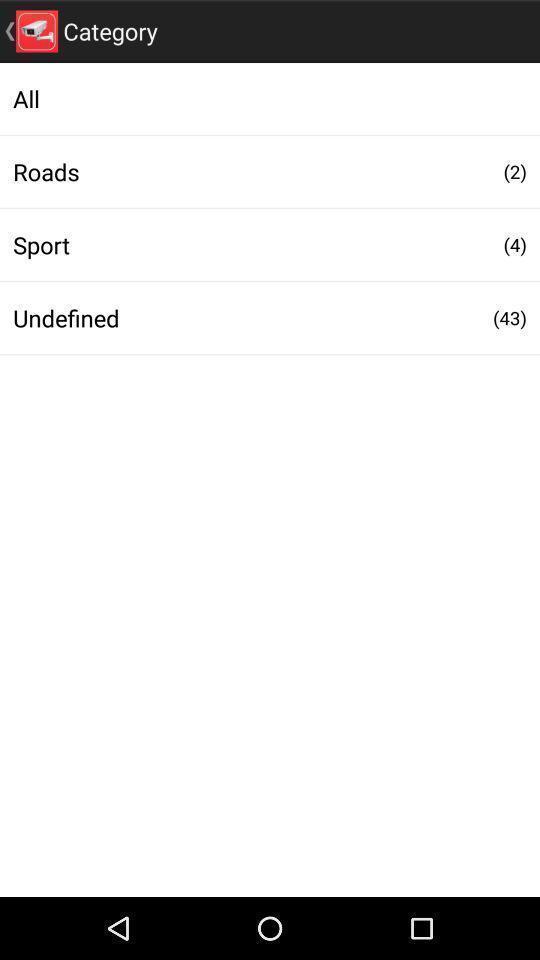Describe the key features of this screenshot. Screen shows a list of categories. 